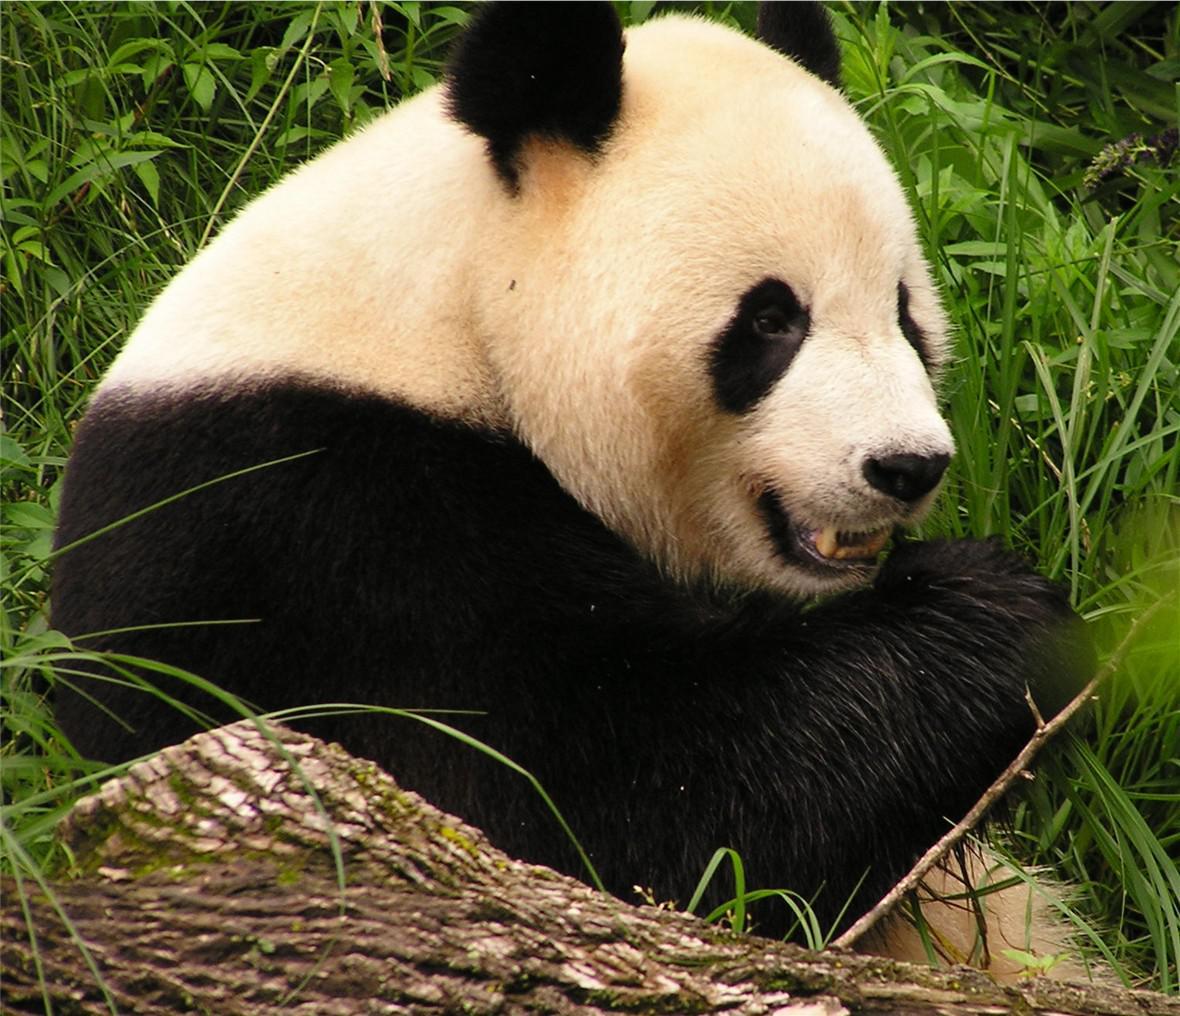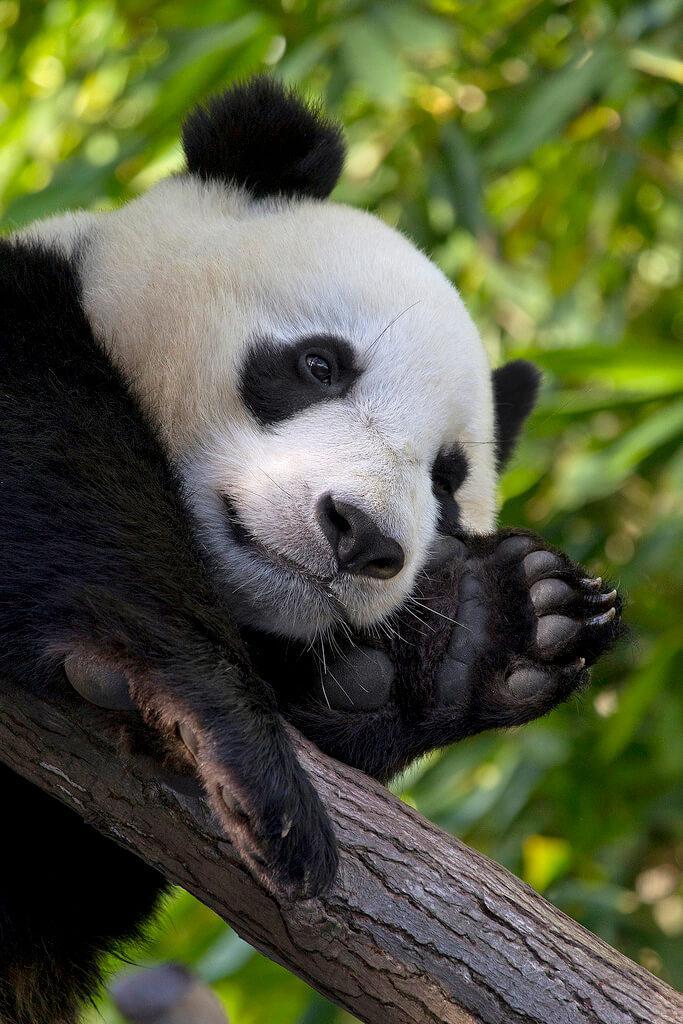The first image is the image on the left, the second image is the image on the right. For the images shown, is this caption "An image features a panda holding something to its mouth and chewing it." true? Answer yes or no. Yes. 